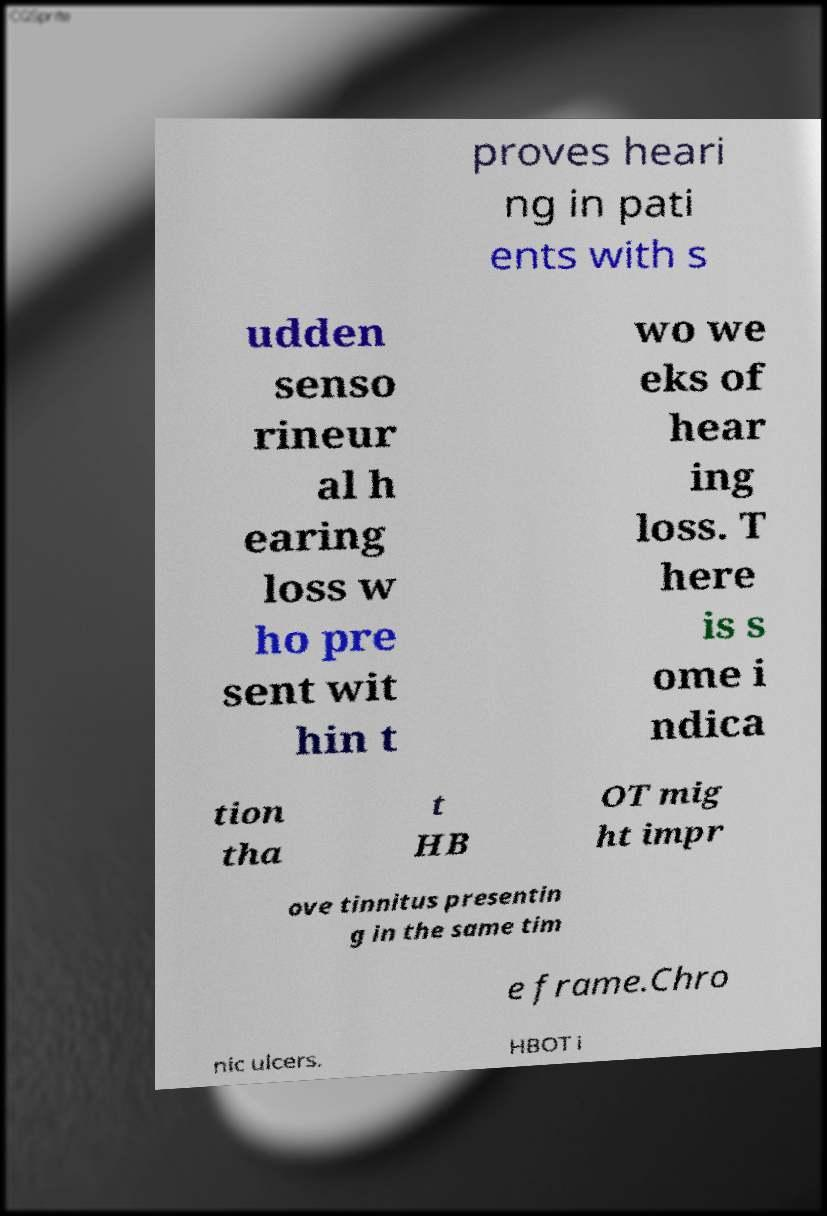Could you assist in decoding the text presented in this image and type it out clearly? proves heari ng in pati ents with s udden senso rineur al h earing loss w ho pre sent wit hin t wo we eks of hear ing loss. T here is s ome i ndica tion tha t HB OT mig ht impr ove tinnitus presentin g in the same tim e frame.Chro nic ulcers. HBOT i 